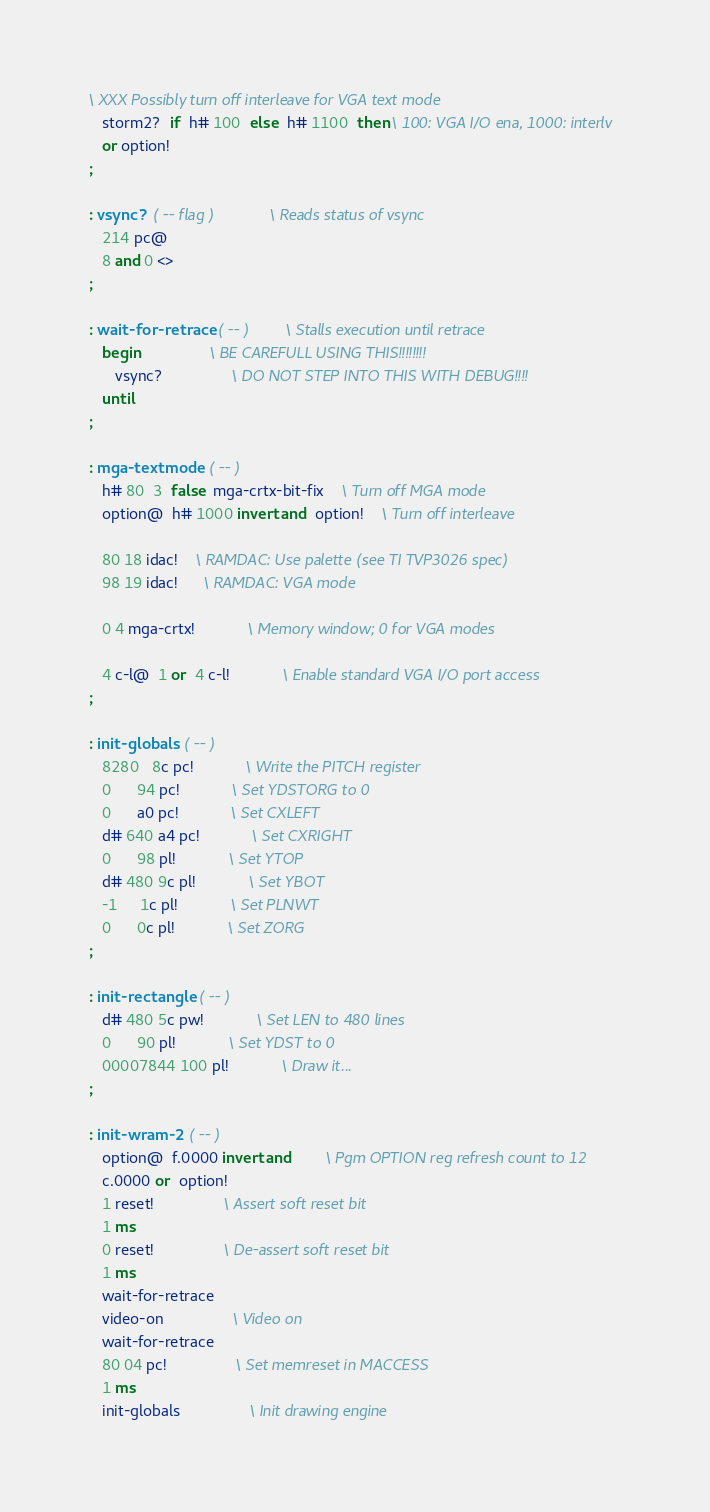<code> <loc_0><loc_0><loc_500><loc_500><_Forth_>\ XXX Possibly turn off interleave for VGA text mode
   storm2?  if  h# 100  else  h# 1100  then \ 100: VGA I/O ena, 1000: interlv
   or option!
;

: vsync?  ( -- flag )			\ Reads status of vsync
   214 pc@
   8 and 0 <>
;

: wait-for-retrace  ( -- )		\ Stalls execution until retrace
   begin				\ BE CAREFULL USING THIS!!!!!!!!
      vsync?				\ DO NOT STEP INTO THIS WITH DEBUG!!!!
   until
;

: mga-textmode  ( -- )
   h# 80  3  false  mga-crtx-bit-fix	\ Turn off MGA mode
   option@  h# 1000 invert and  option!	\ Turn off interleave

   80 18 idac!    \ RAMDAC: Use palette (see TI TVP3026 spec)
   98 19 idac!	  \ RAMDAC: VGA mode

   0 4 mga-crtx!			\ Memory window; 0 for VGA modes

   4 c-l@  1 or  4 c-l!			\ Enable standard VGA I/O port access
;

: init-globals  ( -- )
   8280   8c pc!			\ Write the PITCH register
   0      94 pc!			\ Set YDSTORG to 0
   0      a0 pc!			\ Set CXLEFT
   d# 640 a4 pc!			\ Set CXRIGHT
   0      98 pl!			\ Set YTOP
   d# 480 9c pl!			\ Set YBOT
   -1     1c pl!			\ Set PLNWT
   0      0c pl!			\ Set ZORG
;

: init-rectangle  ( -- )
   d# 480 5c pw!			\ Set LEN to 480 lines
   0      90 pl!			\ Set YDST to 0
   00007844 100 pl!			\ Draw it...
;

: init-wram-2  ( -- )
   option@  f.0000 invert and		\ Pgm OPTION reg refresh count to 12
   c.0000 or  option!
   1 reset!				\ Assert soft reset bit
   1 ms
   0 reset!				\ De-assert soft reset bit
   1 ms
   wait-for-retrace
   video-on				\ Video on
   wait-for-retrace
   80 04 pc!				\ Set memreset in MACCESS
   1 ms
   init-globals				\ Init drawing engine</code> 